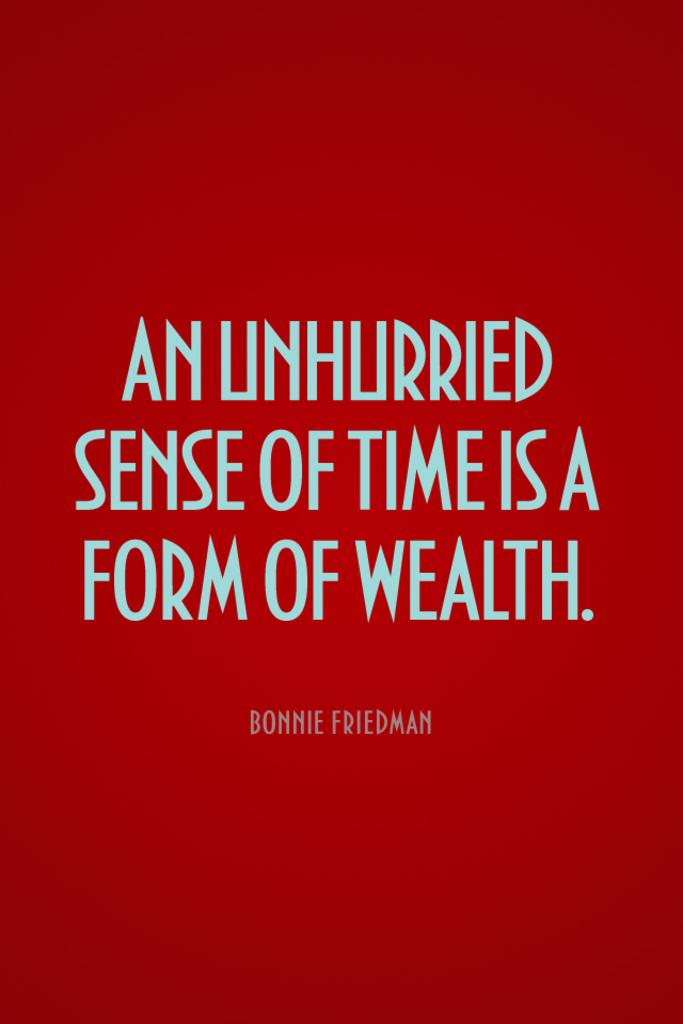Who said this quote?
Provide a succinct answer. Bonnie friedman. What is the book about?
Keep it short and to the point. Unanswerable. 